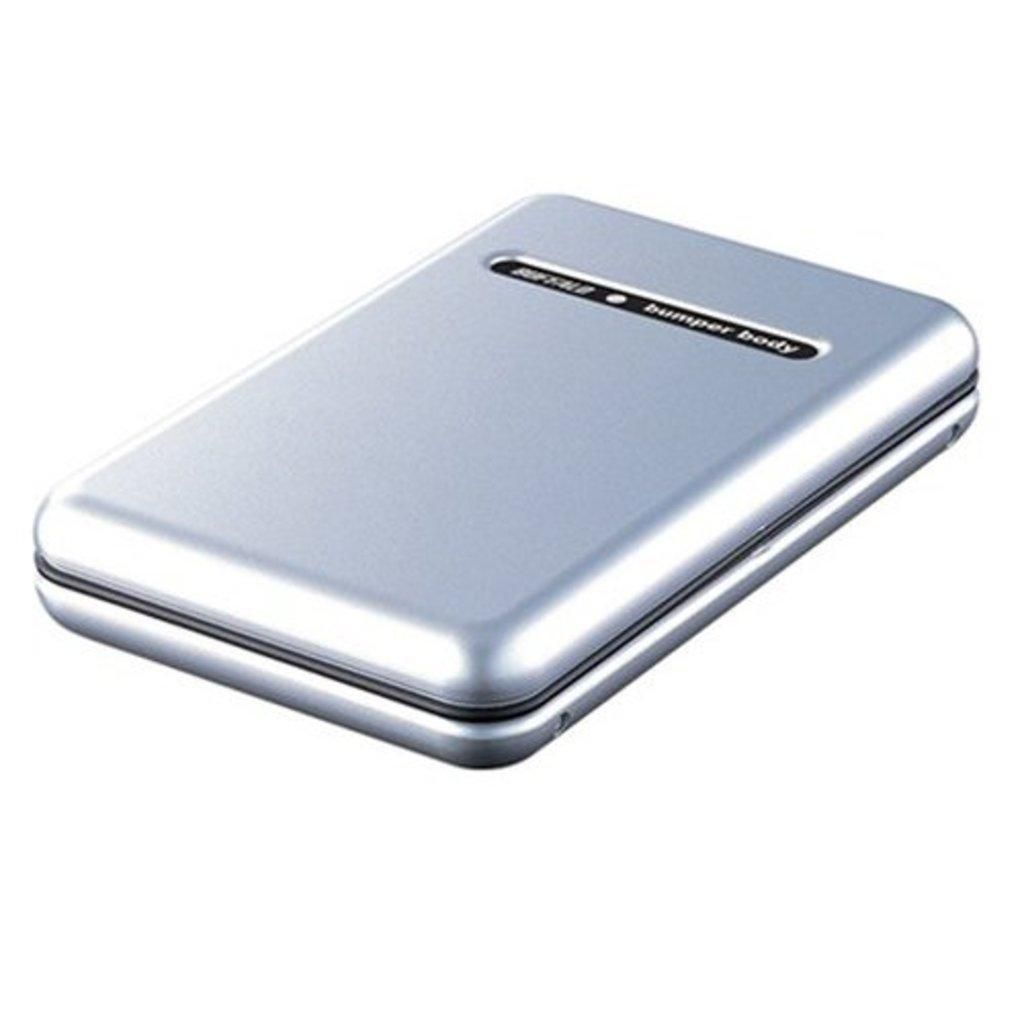<image>
Describe the image concisely. The silver and black book is labeled bumper body. 